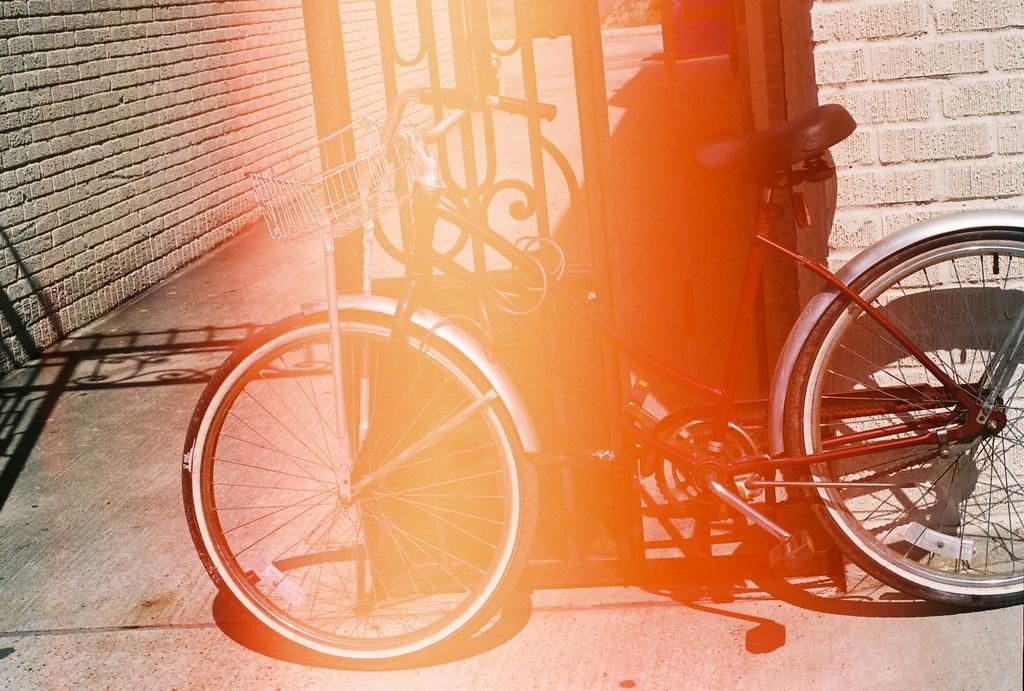What is the main object in the image? There is a bicycle in the image. Where is the bicycle located? The bicycle is parked on a pathway. What is the bicycle's proximity to a door? The bicycle is beside a door. What type of structure can be seen in the image? There is a wall in the image. What type of store is visible in the image? There is no store present in the image; it features a bicycle parked on a pathway beside a door and a wall. What date is marked on the calendar in the image? There is no calendar present in the image. 